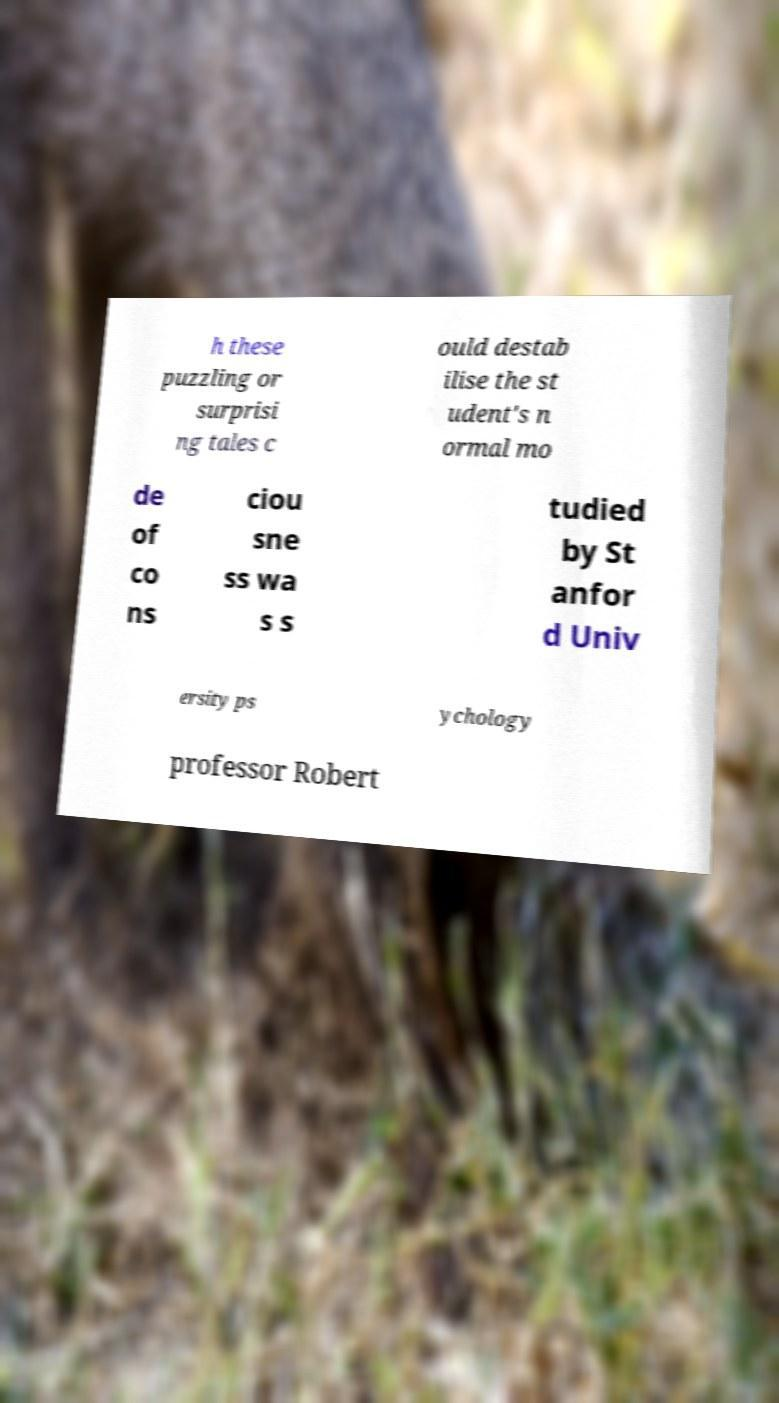Could you assist in decoding the text presented in this image and type it out clearly? h these puzzling or surprisi ng tales c ould destab ilise the st udent's n ormal mo de of co ns ciou sne ss wa s s tudied by St anfor d Univ ersity ps ychology professor Robert 